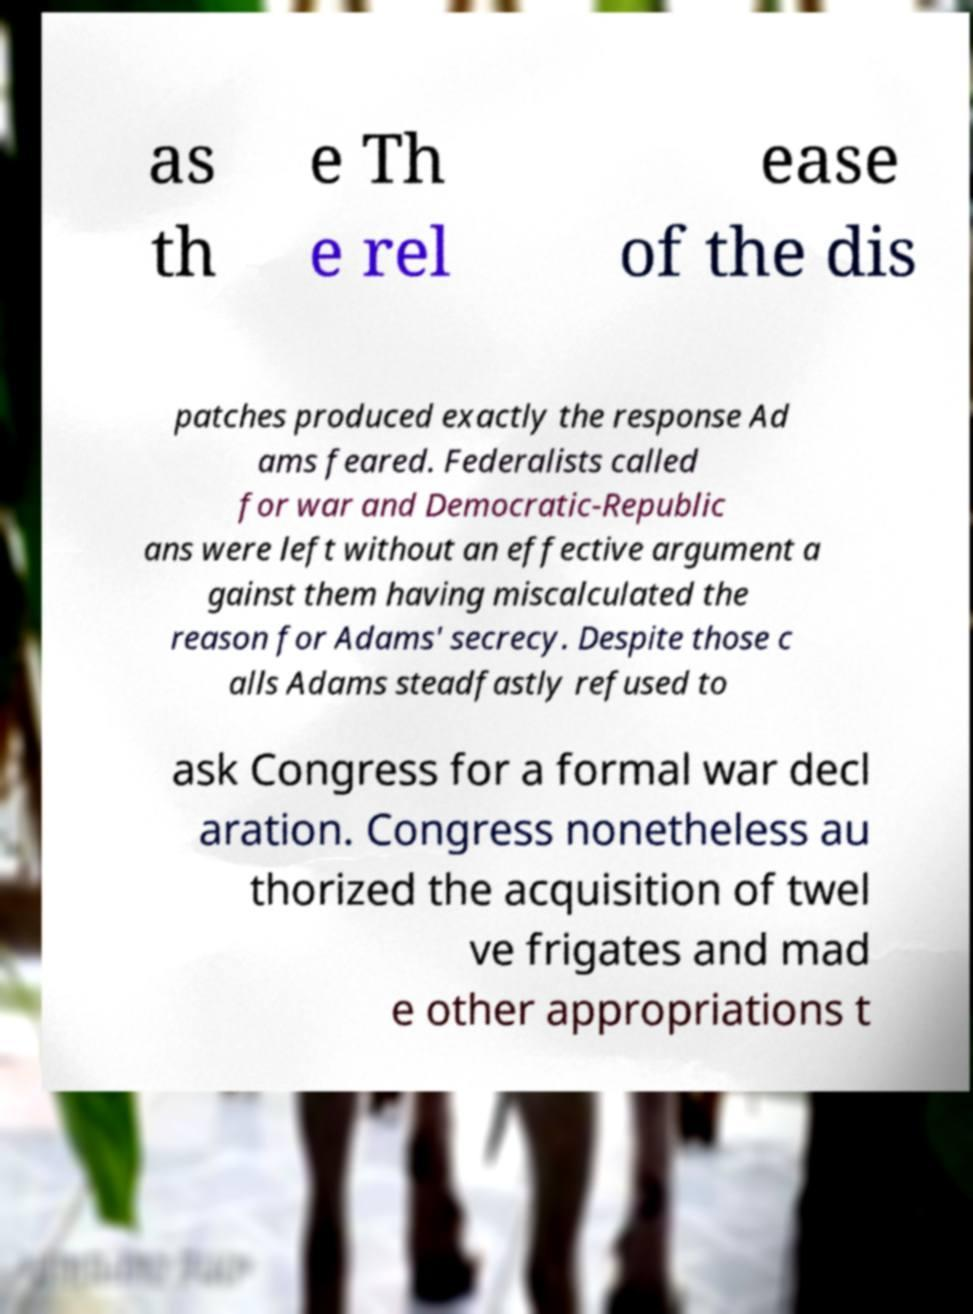There's text embedded in this image that I need extracted. Can you transcribe it verbatim? as th e Th e rel ease of the dis patches produced exactly the response Ad ams feared. Federalists called for war and Democratic-Republic ans were left without an effective argument a gainst them having miscalculated the reason for Adams' secrecy. Despite those c alls Adams steadfastly refused to ask Congress for a formal war decl aration. Congress nonetheless au thorized the acquisition of twel ve frigates and mad e other appropriations t 